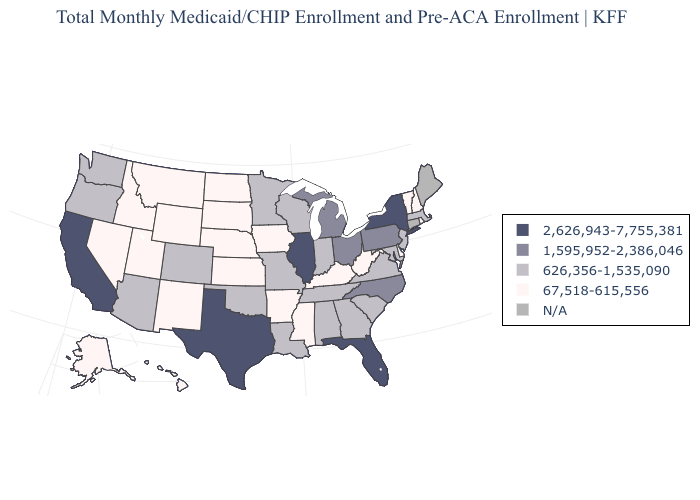Does Illinois have the highest value in the MidWest?
Write a very short answer. Yes. What is the value of Missouri?
Be succinct. 626,356-1,535,090. Does Pennsylvania have the highest value in the USA?
Be succinct. No. What is the value of New Hampshire?
Short answer required. 67,518-615,556. Name the states that have a value in the range 67,518-615,556?
Concise answer only. Alaska, Arkansas, Delaware, Hawaii, Idaho, Iowa, Kansas, Kentucky, Mississippi, Montana, Nebraska, Nevada, New Hampshire, New Mexico, North Dakota, Rhode Island, South Dakota, Utah, Vermont, West Virginia, Wyoming. What is the value of Nevada?
Keep it brief. 67,518-615,556. What is the value of Virginia?
Keep it brief. 626,356-1,535,090. What is the lowest value in the USA?
Keep it brief. 67,518-615,556. Does California have the highest value in the USA?
Write a very short answer. Yes. Does Vermont have the lowest value in the Northeast?
Give a very brief answer. Yes. Does the map have missing data?
Short answer required. Yes. Among the states that border Nevada , which have the lowest value?
Quick response, please. Idaho, Utah. What is the value of Vermont?
Quick response, please. 67,518-615,556. What is the highest value in the USA?
Keep it brief. 2,626,943-7,755,381. What is the value of New Mexico?
Give a very brief answer. 67,518-615,556. 